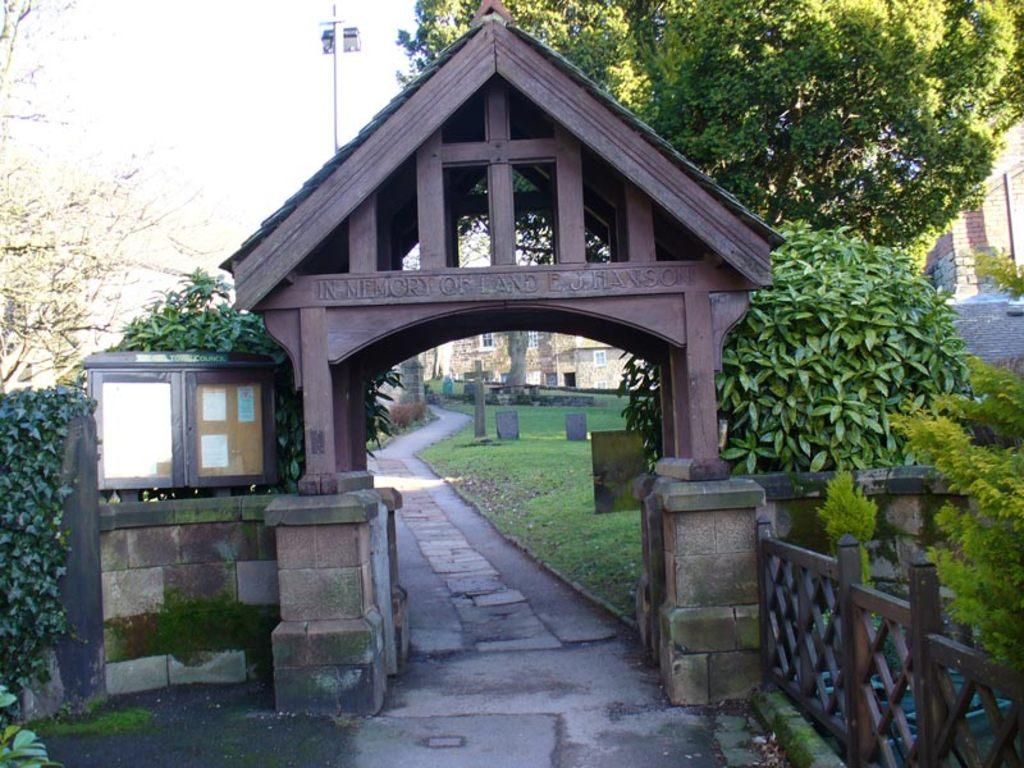What is the main structure visible in the image? There is an entrance arch in the image. What type of grills are present in the image? There are wooden grills in the image. What type of vegetation can be seen in the image? Creepers, plants, and trees are present in the image. What type of markers are visible in the image? Grave stones are in the image. What type of structures can be seen in the image? There are buildings in the image. What is visible in the background of the image? The sky is visible in the image. What type of appliance is being used by the ghost in the image? There is no ghost or appliance present in the image. How many police officers are visible in the image? There are no police officers present in the image. 